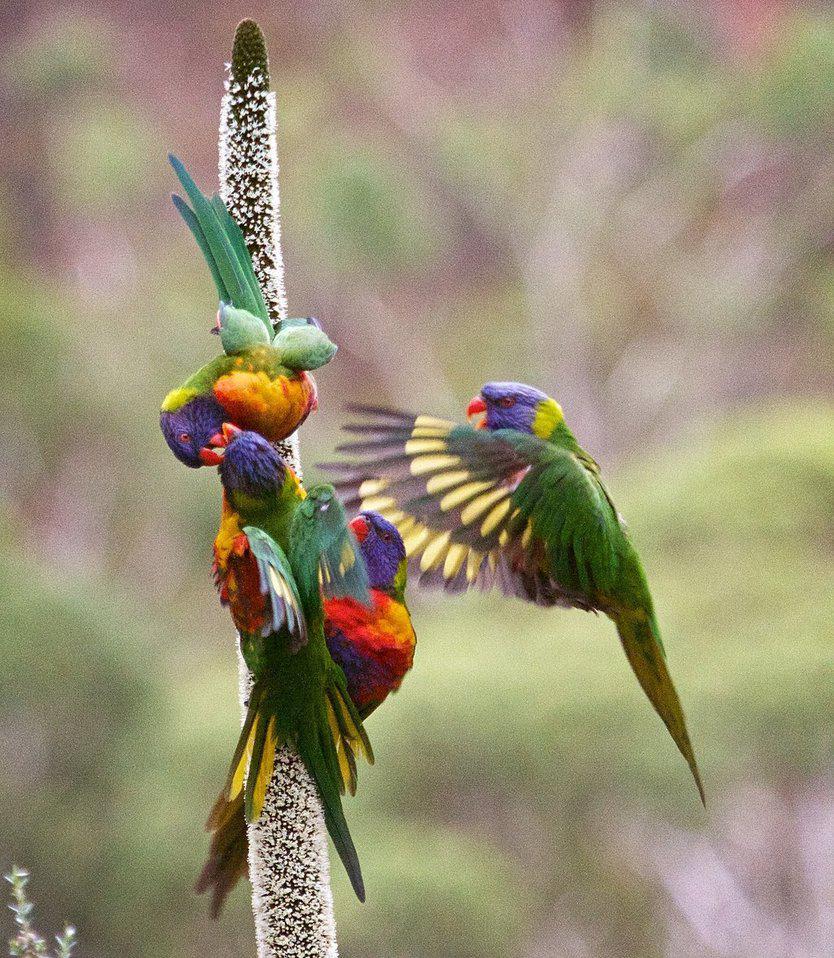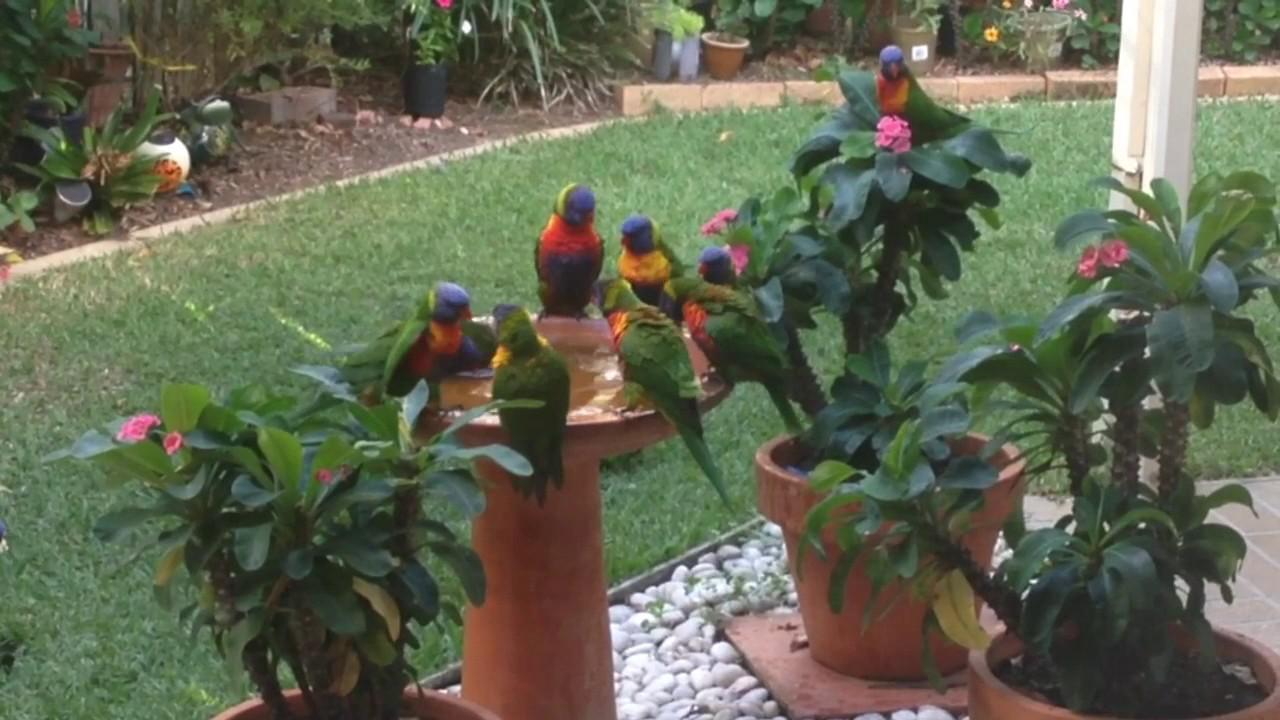The first image is the image on the left, the second image is the image on the right. Analyze the images presented: Is the assertion "In at least one of the images there are four or more rainbow lorikeets gathered together." valid? Answer yes or no. Yes. The first image is the image on the left, the second image is the image on the right. For the images shown, is this caption "There is at most four rainbow lorikeets." true? Answer yes or no. No. 